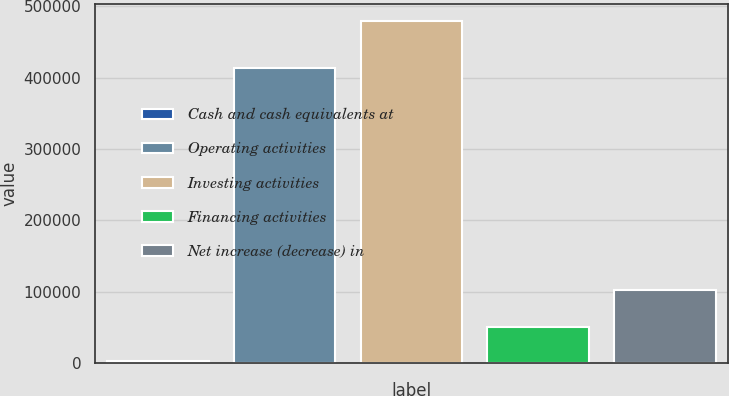Convert chart to OTSL. <chart><loc_0><loc_0><loc_500><loc_500><bar_chart><fcel>Cash and cash equivalents at<fcel>Operating activities<fcel>Investing activities<fcel>Financing activities<fcel>Net increase (decrease) in<nl><fcel>2743<fcel>413017<fcel>479276<fcel>50396.3<fcel>102542<nl></chart> 